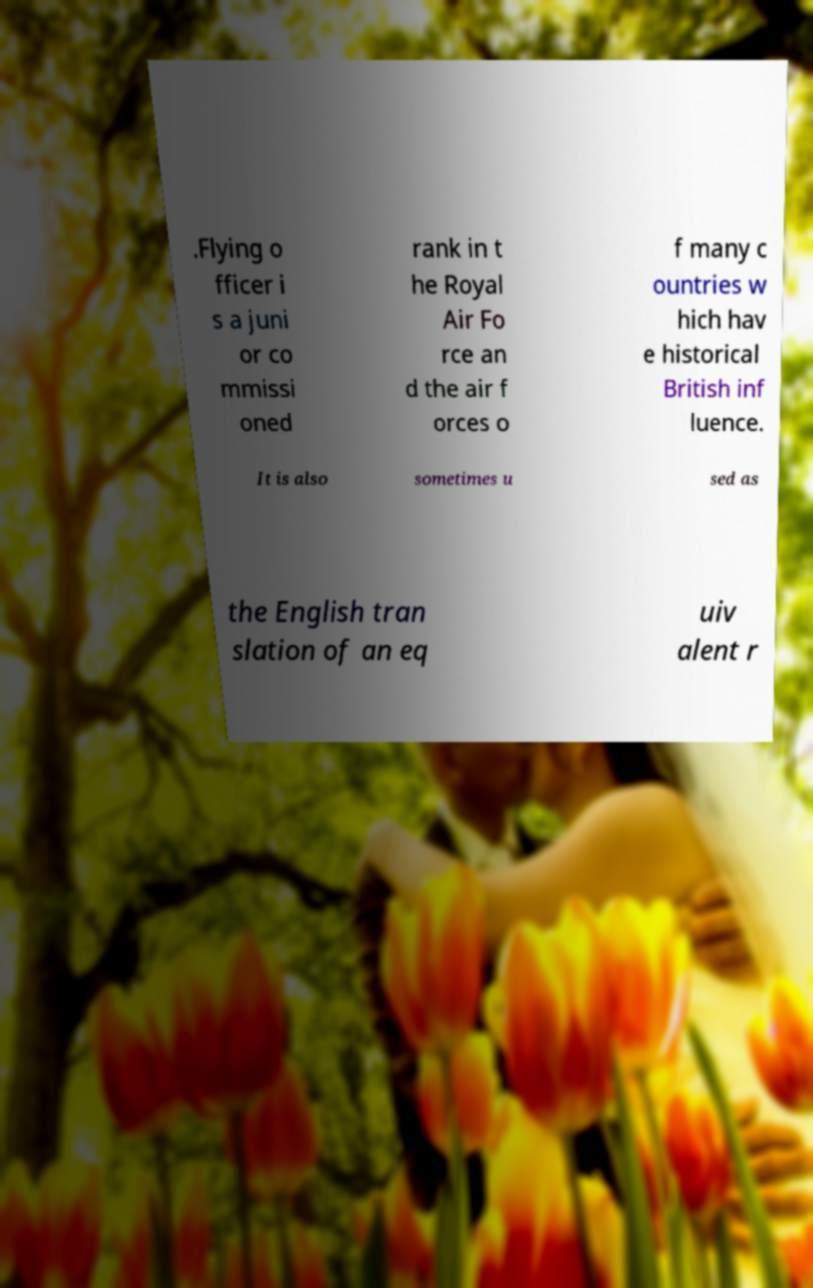There's text embedded in this image that I need extracted. Can you transcribe it verbatim? .Flying o fficer i s a juni or co mmissi oned rank in t he Royal Air Fo rce an d the air f orces o f many c ountries w hich hav e historical British inf luence. It is also sometimes u sed as the English tran slation of an eq uiv alent r 